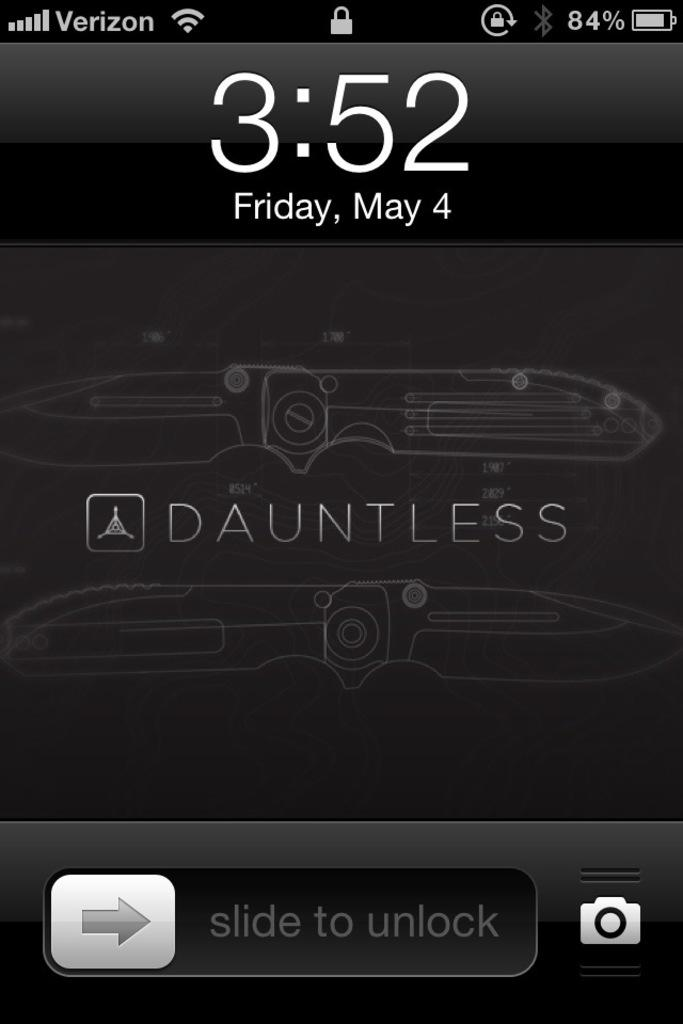<image>
Offer a succinct explanation of the picture presented. A screenshot of a Verizon phone showing a Dauntless brand knife. 